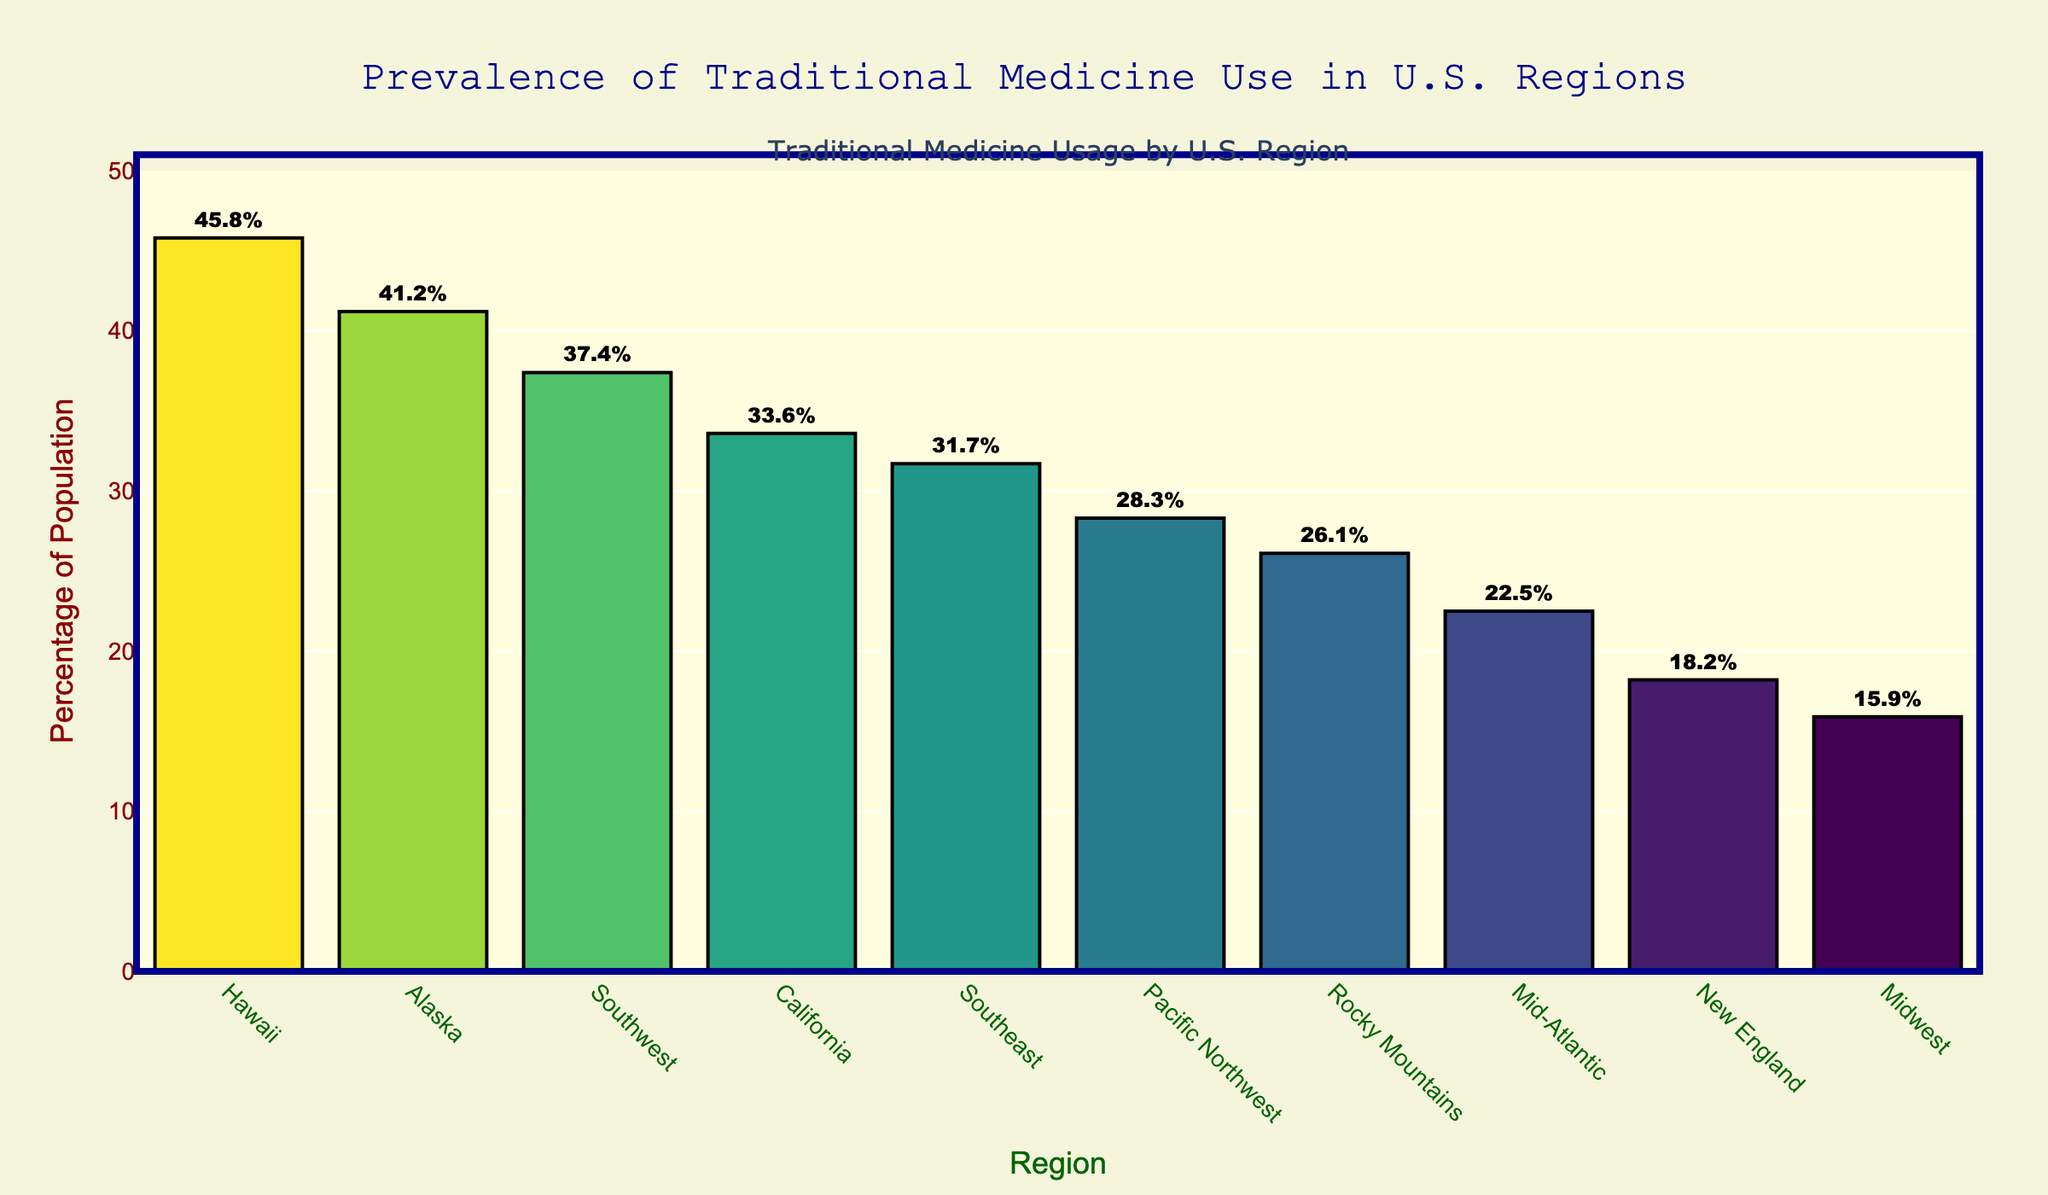What's the percentage of the population using traditional medicine in the Hawaii region? Locate the bar labeled "Hawaii" and refer to the percentage indicated next to it.
Answer: 45.8% Which region has the lowest usage of traditional medicine? Identify the shortest bar in the figure and read the region label associated with it.
Answer: Midwest What is the difference in percentage usage between Hawaii and New England? Find the percentages for Hawaii (45.8%) and New England (18.2%). Subtract New England's value from Hawaii's value. 45.8% - 18.2% = 27.6%
Answer: 27.6% Which regions have a traditional medicine usage higher than 30%? Identify all bars that exceed the 30% mark on the y-axis and read their labels. The regions are Southeast, Southwest, California, Alaska, and Hawaii.
Answer: Southeast, Southwest, California, Alaska, Hawaii How much higher is the traditional medicine usage in Alaska compared to the Mid-Atlantic region? Find the percentages for Alaska (41.2%) and Mid-Atlantic (22.5%). Subtract Mid-Atlantic's value from Alaska's value. 41.2% - 22.5% = 18.7%
Answer: 18.7% What's the average percentage of traditional medicine usage in the California and Pacific Northwest regions? Find the percentages for California (33.6%) and Pacific Northwest (28.3%). Add these values and divide by 2. (33.6% + 28.3%) / 2 = 30.95%
Answer: 30.95% Are there more regions with usage below or above 30%? Count the number of bars above and below the 30% mark. Regions above 30%: 5. Regions below 30%: 5. Both groups have equal counts.
Answer: Equal Which region shows a usage that is closest to 35%? Compare the bars to find the percentage closest to 35%. California at 33.6% is the closest.
Answer: California How does the traditional medicine usage in the Pacific Northwest compare to that in the Southeast? Find the percentages for both regions. Pacific Northwest: 28.3%, Southeast: 31.7%. Compare the values and note Pacific Northwest is lower.
Answer: Lower 